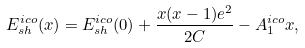<formula> <loc_0><loc_0><loc_500><loc_500>E ^ { i c o } _ { s h } ( x ) = E ^ { i c o } _ { s h } ( 0 ) + \frac { x ( x - 1 ) e ^ { 2 } } { 2 C } - A ^ { i c o } _ { 1 } x ,</formula> 